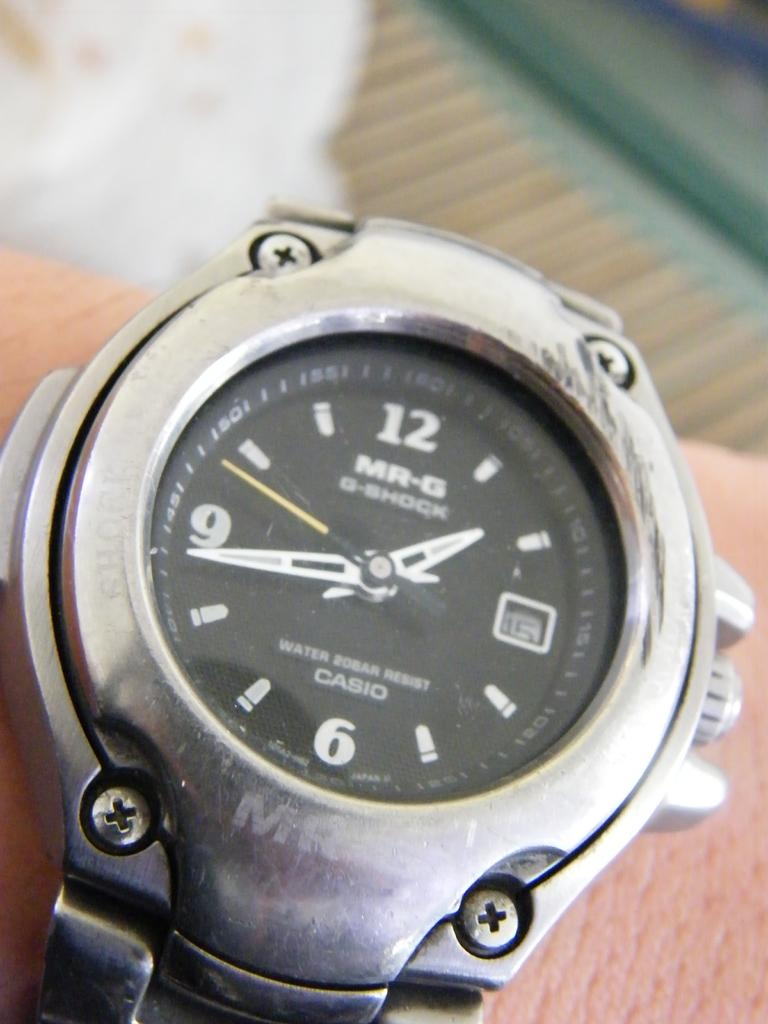<image>
Provide a brief description of the given image. A silver Casio watch with MR-G on it. 